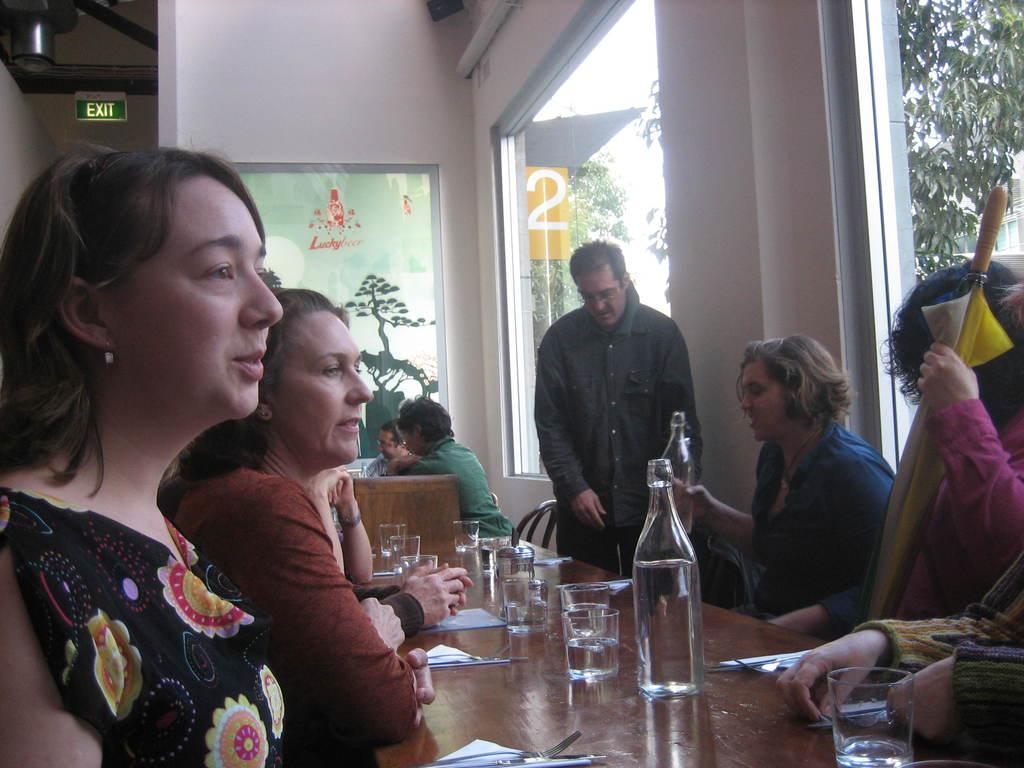How would you summarize this image in a sentence or two? There is a group of people. They are sitting on a chairs. There is a table. There is a glass ,bottle ,paper on a table. We can see in background windows and trees. 